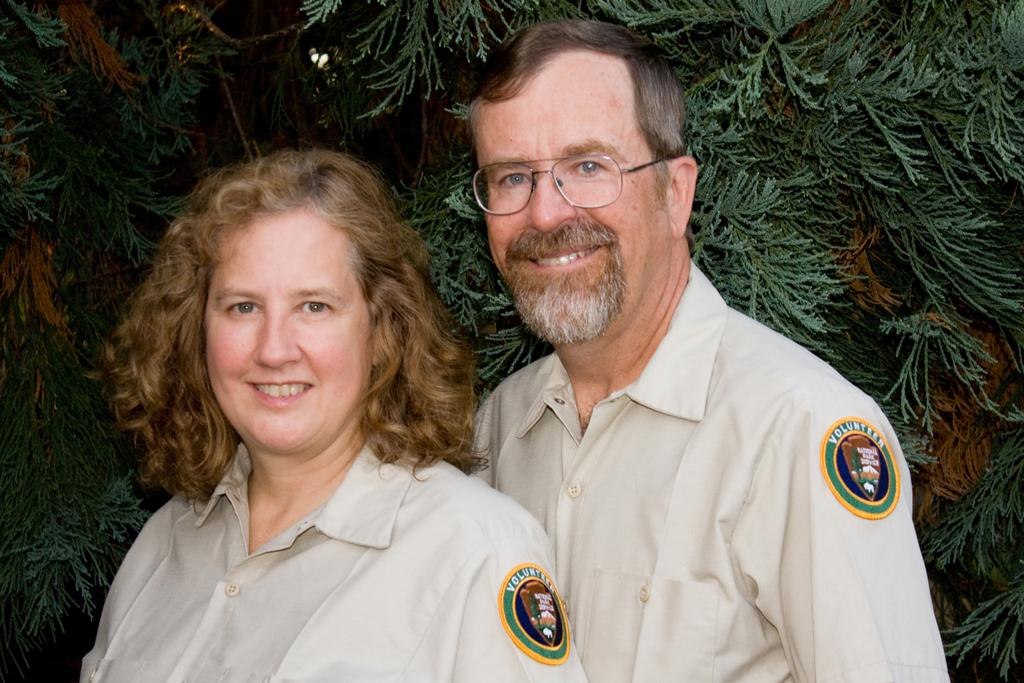Who is present in the image? There is a man and a woman in the image. What can be observed about the man's appearance? The man is wearing glasses. What can be seen in the background of the image? There are leaves in the background of the image. What is the weight of the monkey in the image? There is no monkey present in the image, so its weight cannot be determined. 